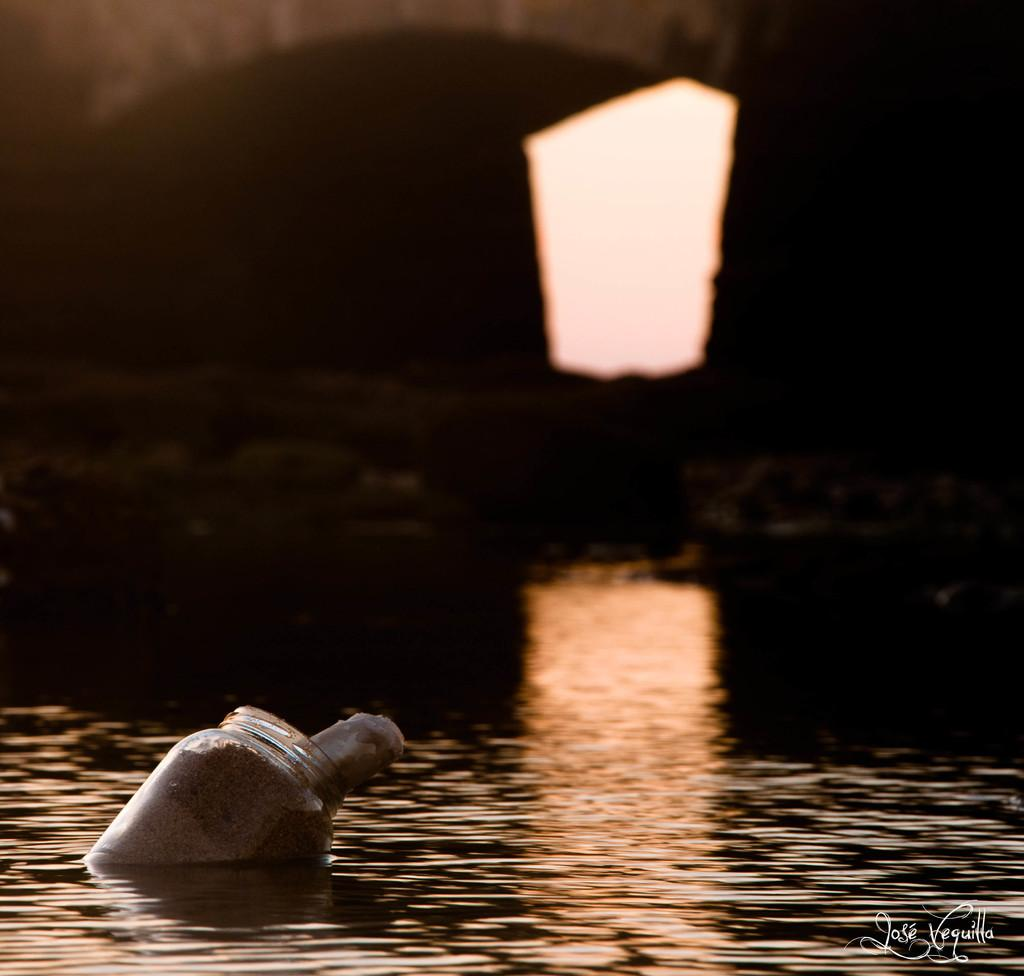What is the primary element in the image? There is water in the image. What object can be seen floating in the water? A jar is floating in the water. What can be seen in the background of the image? There is a bridge in the background of the image. What type of organization is depicted in the image? There is no organization depicted in the image; it features water, a floating jar, and a bridge in the background. What kind of cake can be seen on the bridge in the image? There is no cake present in the image; it only shows water, a floating jar, and a bridge in the background. 